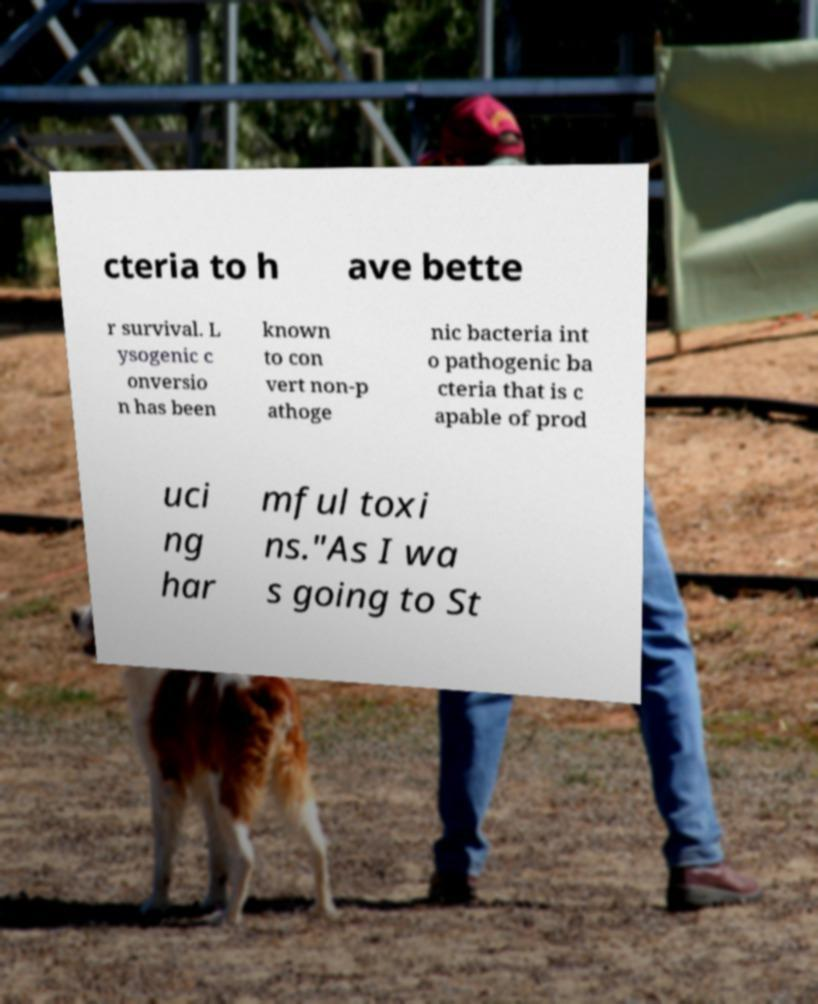Can you read and provide the text displayed in the image?This photo seems to have some interesting text. Can you extract and type it out for me? cteria to h ave bette r survival. L ysogenic c onversio n has been known to con vert non-p athoge nic bacteria int o pathogenic ba cteria that is c apable of prod uci ng har mful toxi ns."As I wa s going to St 